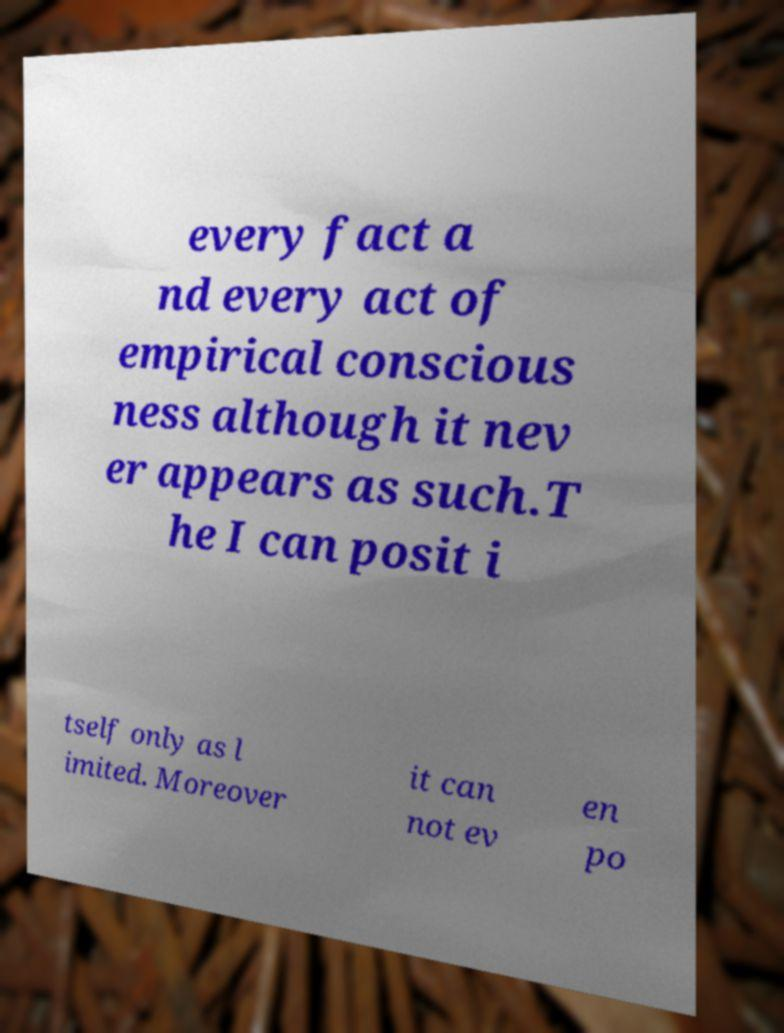There's text embedded in this image that I need extracted. Can you transcribe it verbatim? every fact a nd every act of empirical conscious ness although it nev er appears as such.T he I can posit i tself only as l imited. Moreover it can not ev en po 